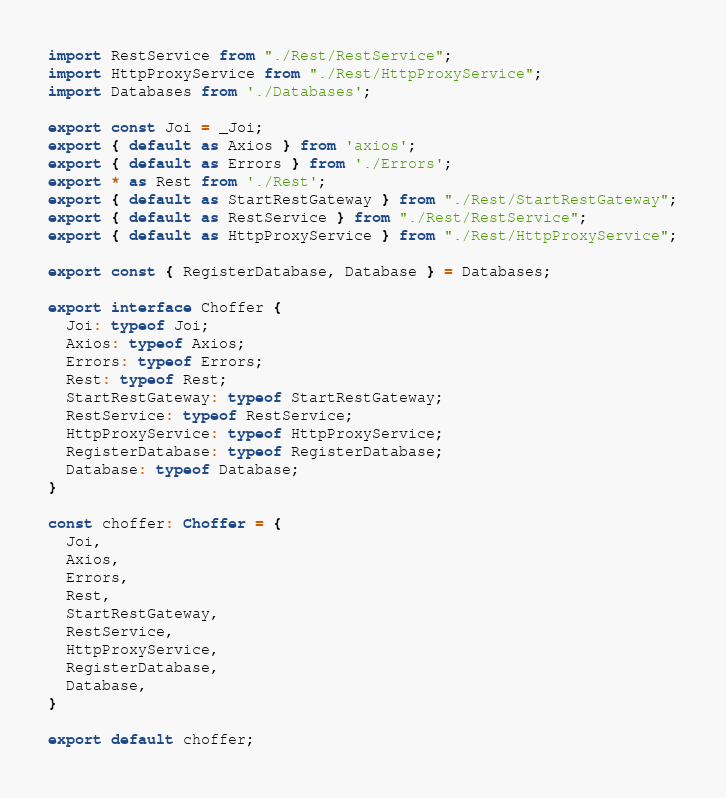Convert code to text. <code><loc_0><loc_0><loc_500><loc_500><_TypeScript_>import RestService from "./Rest/RestService";
import HttpProxyService from "./Rest/HttpProxyService";
import Databases from './Databases';

export const Joi = _Joi;
export { default as Axios } from 'axios';
export { default as Errors } from './Errors';
export * as Rest from './Rest';
export { default as StartRestGateway } from "./Rest/StartRestGateway";
export { default as RestService } from "./Rest/RestService";
export { default as HttpProxyService } from "./Rest/HttpProxyService";

export const { RegisterDatabase, Database } = Databases;

export interface Choffer {
  Joi: typeof Joi;
  Axios: typeof Axios;
  Errors: typeof Errors;
  Rest: typeof Rest;
  StartRestGateway: typeof StartRestGateway;
  RestService: typeof RestService;
  HttpProxyService: typeof HttpProxyService;
  RegisterDatabase: typeof RegisterDatabase;
  Database: typeof Database;
}

const choffer: Choffer = {
  Joi,
  Axios,
  Errors,
  Rest,
  StartRestGateway,
  RestService,
  HttpProxyService,
  RegisterDatabase,
  Database,
}

export default choffer;
</code> 